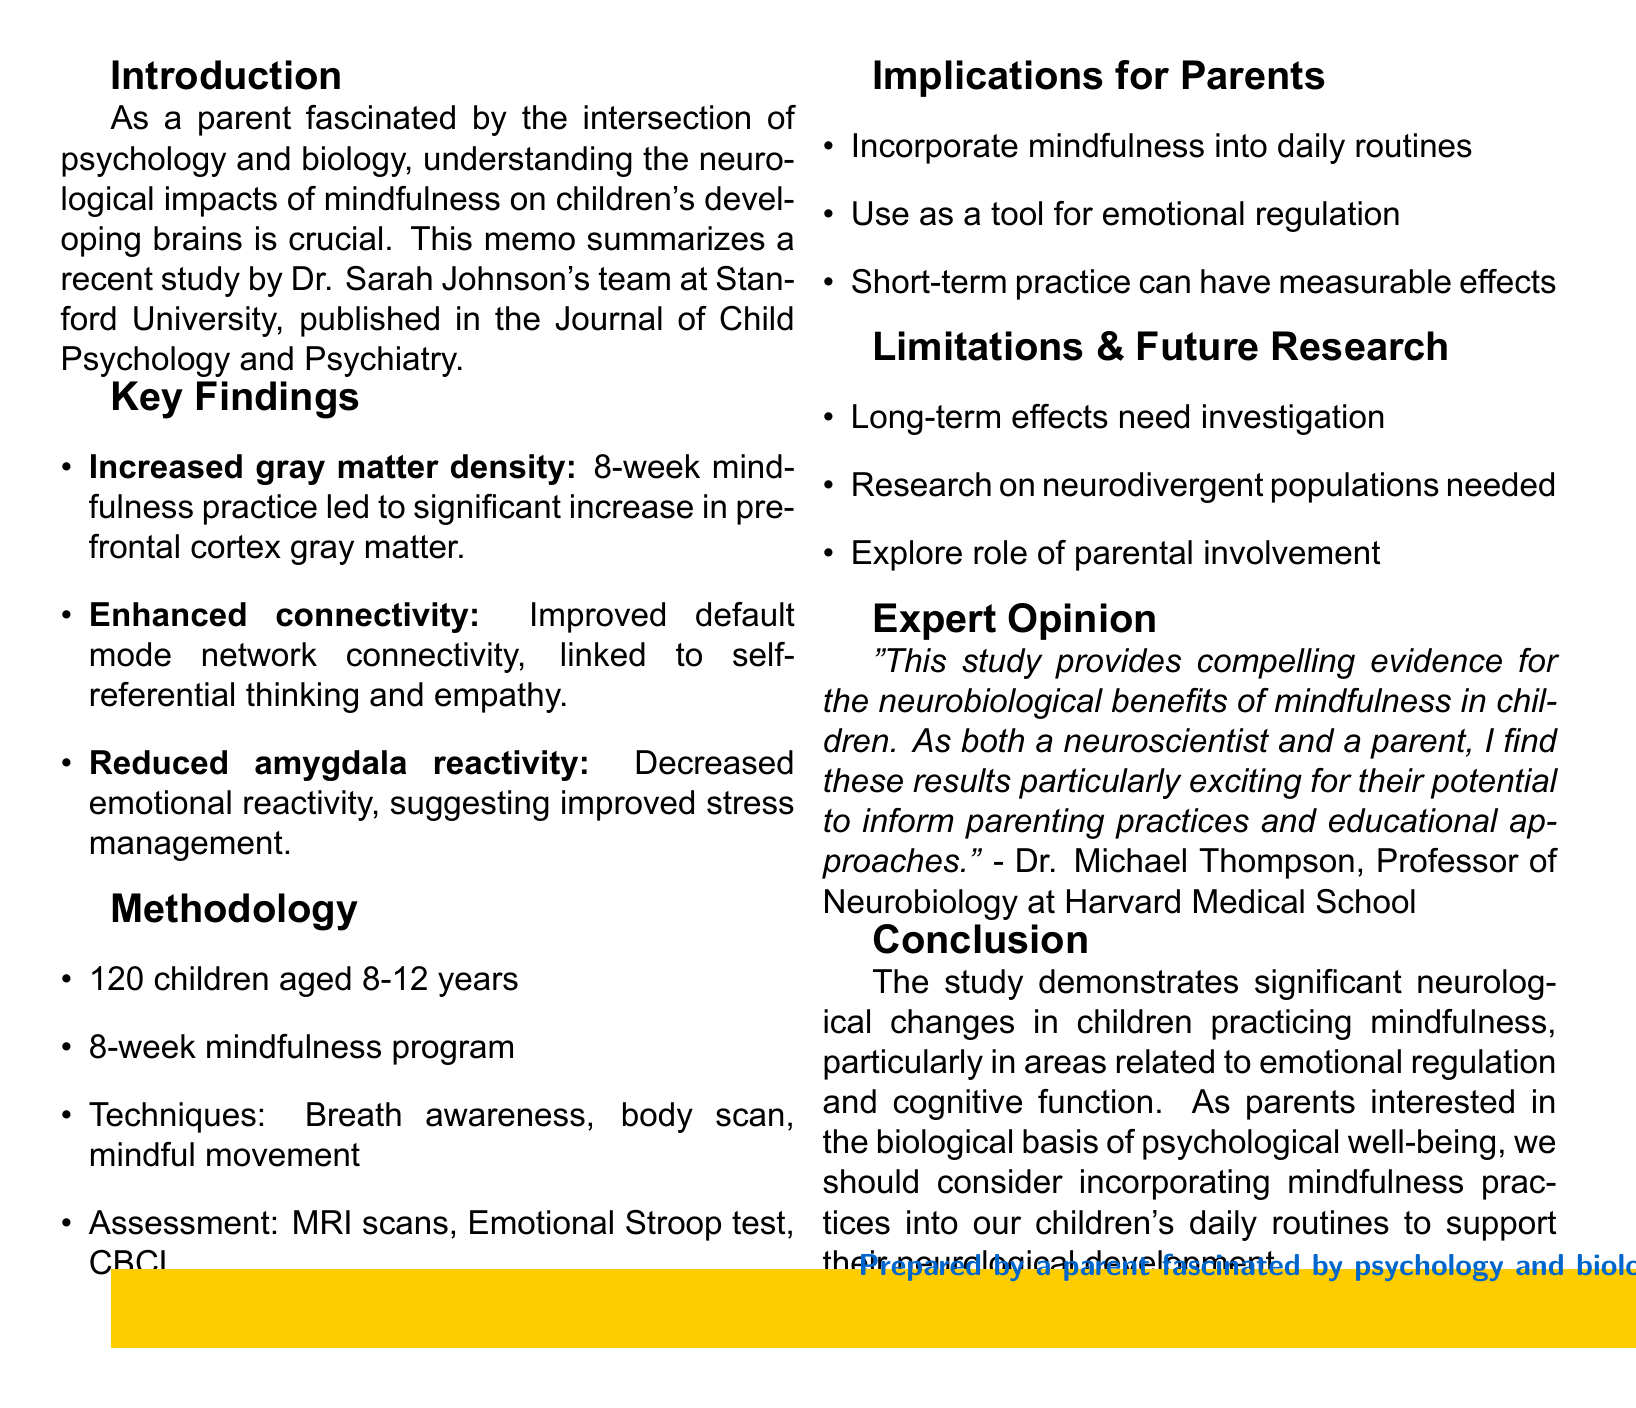What is the title of the research summary? The title mentions the neurological effects of mindfulness practices on children.
Answer: Neurological Effects of Mindfulness Practices on Children: A Research Summary Who conducted the study? The document states that the study was conducted by Dr. Sarah Johnson and her team.
Answer: Dr. Sarah Johnson What area of the brain showed increased gray matter density? The prefrontal cortex is associated with executive function and emotional regulation.
Answer: Prefrontal cortex How long was the mindfulness program? The program lasted for 8 weeks, as stated in the methodology section.
Answer: 8 weeks Which technique was used in the mindfulness program? The techniques included breath awareness exercises, among others.
Answer: Breath awareness exercises What type of scan was used to assess brain changes? Pre and post-intervention MRI scans were used to measure changes in the brain.
Answer: MRI scans What is one implication for parents mentioned in the document? Parents are encouraged to incorporate mindfulness practices into daily routines.
Answer: Incorporate mindfulness into daily routines What is a limitation of the study? The long-term effects of mindfulness on children's brain development need further investigation.
Answer: Long-term effects need investigation What expert opinion is included in the document? Dr. Michael Thompson provides a compelling evidence for the neurobiological benefits of mindfulness.
Answer: Compelling evidence for neurobiological benefits What is the main conclusion of the study? The study demonstrates significant neurological changes related to emotional regulation and cognitive function.
Answer: Significant neurological changes 